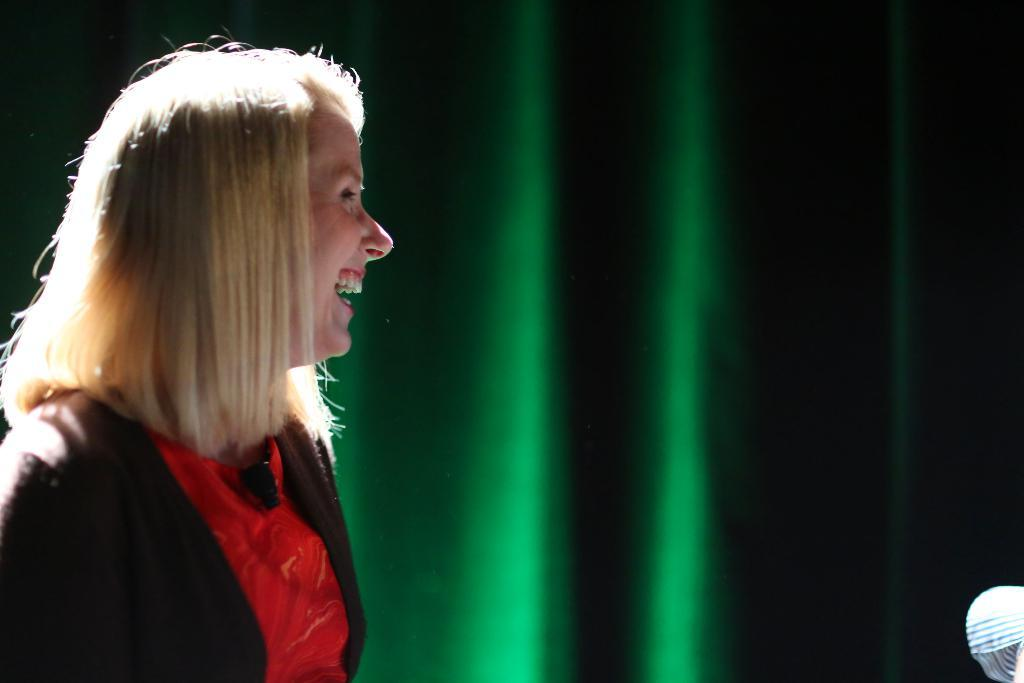What is present in the image? There is a person in the image. Can you describe the person's attire? The person is wearing clothes. What type of sand can be seen on the person's apparel in the image? There is no sand present in the image, and the person's attire is not described in enough detail to determine if there is any apparel. 